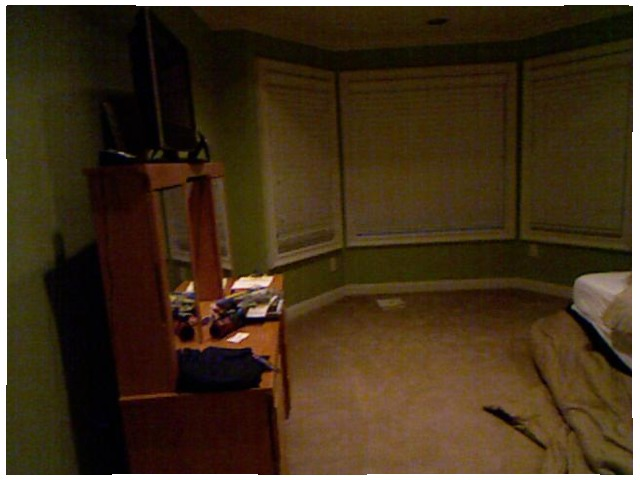<image>
Can you confirm if the window is on the wall? Yes. Looking at the image, I can see the window is positioned on top of the wall, with the wall providing support. 